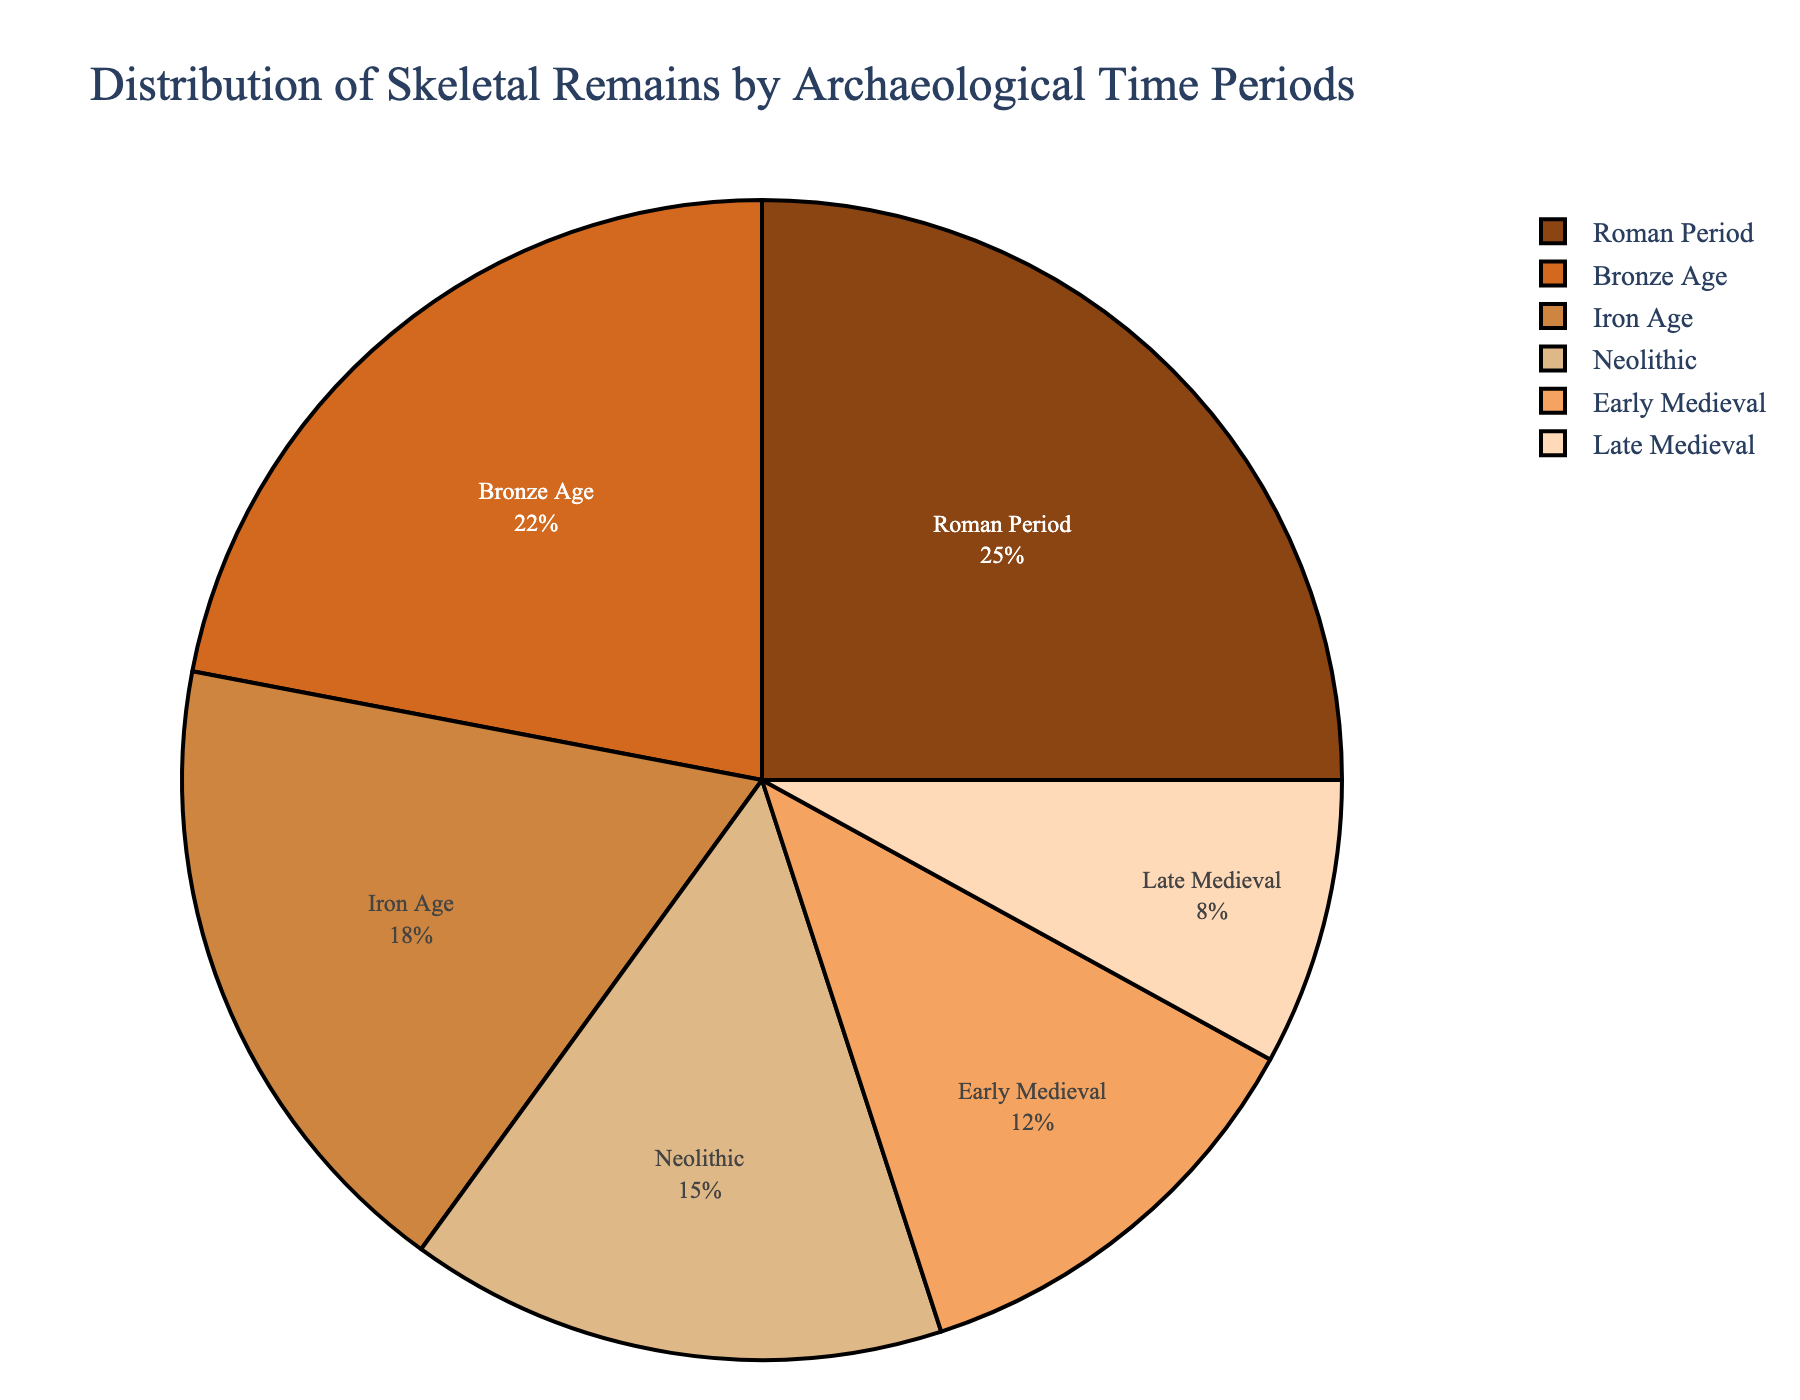What is the time period with the highest percentage of skeletal remains? To determine the time period with the highest percentage, examine all the slices of the pie chart and identify the largest one. It is labeled "Roman Period" with 25%.
Answer: Roman Period Which period has a higher percentage of skeletal remains: Neolithic or Early Medieval? Compare the percentages labeled around the slices for both time periods. Neolithic is labeled 15% and Early Medieval is labeled 12%.
Answer: Neolithic What is the total percentage of skeletal remains for the Neolithic and Iron Age combined? Add the percentages of Neolithic and Iron Age: 15% (Neolithic) + 18% (Iron Age) = 33%.
Answer: 33% Which period has the lowest percentage of skeletal remains? Look for the smallest slice in the pie chart. It is labeled "Late Medieval" with 8%.
Answer: Late Medieval How does the percentage of skeletal remains in the Bronze Age compare to the Iron Age? Compare the percentages directly: Bronze Age has 22% while Iron Age has 18%, making Bronze Age greater.
Answer: Bronze Age has a higher percentage What is the average percentage of skeletal remains for the Iron Age, Roman Period, and Early Medieval combined? Add the percentages of Iron Age, Roman Period, and Early Medieval, then divide by 3: (18% + 25% + 12%) / 3 = 18.33%.
Answer: 18.33% What color represents the Roman Period in the pie chart? Identify the color of the slice labeled "Roman Period", which is the fourth one in sequence. It is beige.
Answer: Beige How does the percentage of skeletal remains in the Early Medieval period compare to that in the Late Medieval period? Compare the percentages labeled around the slices for both time periods: Early Medieval is 12% and Late Medieval is 8%. Early Medieval has a higher percentage than Late Medieval.
Answer: Early Medieval is higher Is the sum of the percentages for Neolithic and Bronze Age greater than the percentage for the Roman Period? Add Neolithic (15%) and Bronze Age (22%) to get 37%. Compare this to the Roman Period (25%), 37% is greater than 25%.
Answer: Yes What is the difference in the percentage of skeletal remains between the Iron Age and the Early Medieval period? Subtract the percentage of the Early Medieval period from that of the Iron Age: 18% - 12% = 6%.
Answer: 6% 